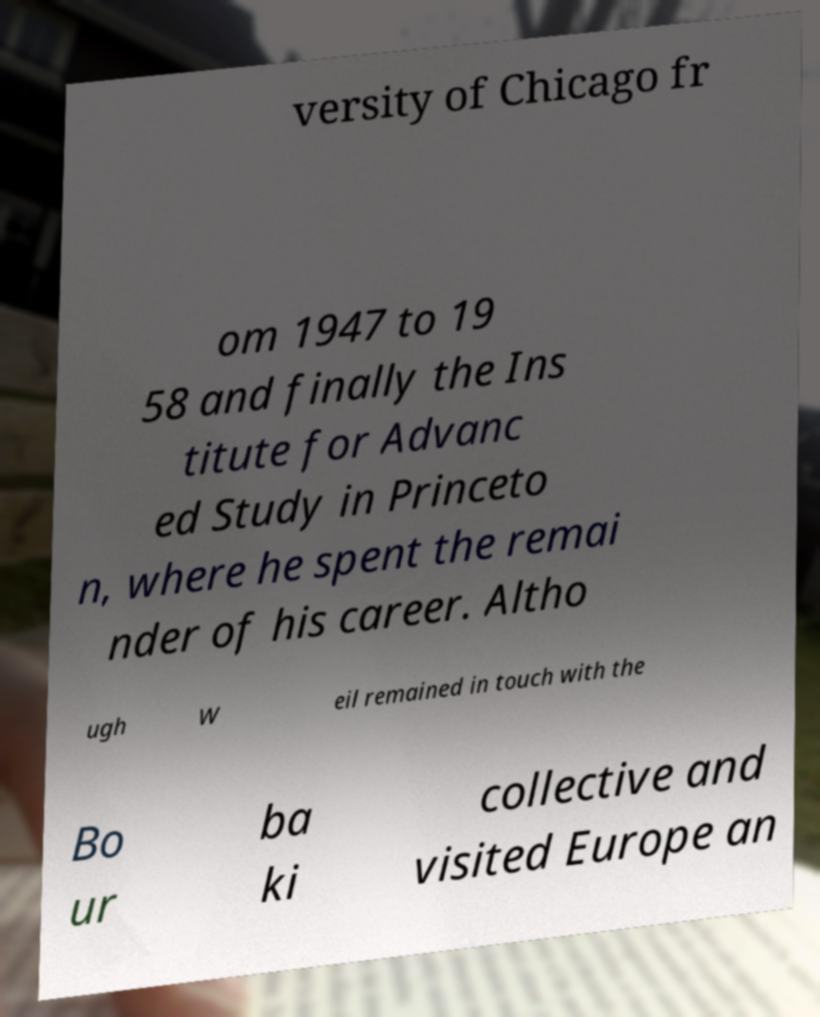What messages or text are displayed in this image? I need them in a readable, typed format. versity of Chicago fr om 1947 to 19 58 and finally the Ins titute for Advanc ed Study in Princeto n, where he spent the remai nder of his career. Altho ugh W eil remained in touch with the Bo ur ba ki collective and visited Europe an 